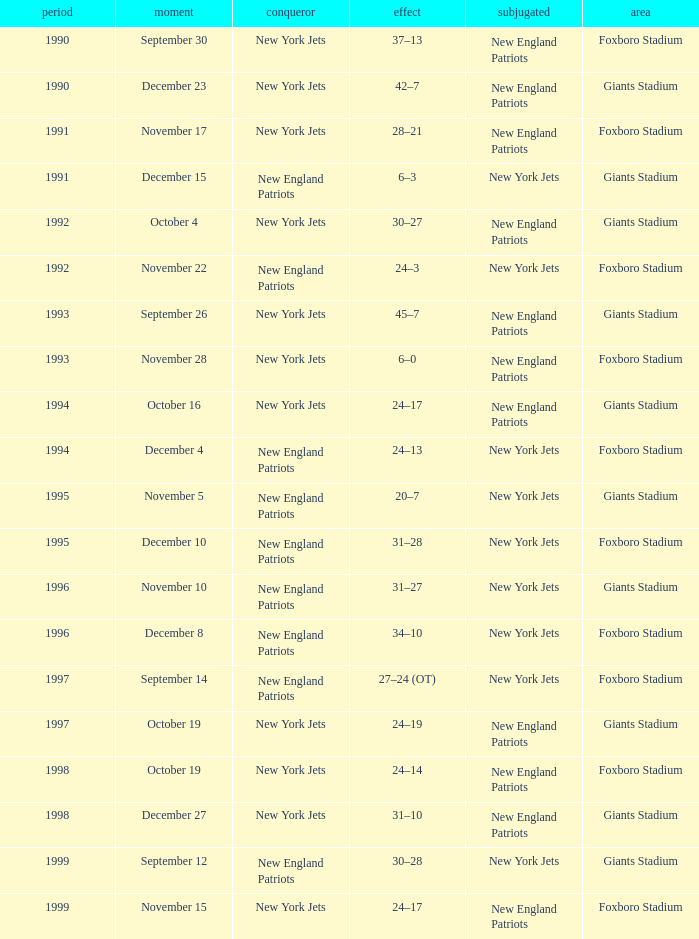What team was the lower when the winner was the new york jets, and a Year earlier than 1994, and a Result of 37–13? New England Patriots. Could you help me parse every detail presented in this table? {'header': ['period', 'moment', 'conqueror', 'effect', 'subjugated', 'area'], 'rows': [['1990', 'September 30', 'New York Jets', '37–13', 'New England Patriots', 'Foxboro Stadium'], ['1990', 'December 23', 'New York Jets', '42–7', 'New England Patriots', 'Giants Stadium'], ['1991', 'November 17', 'New York Jets', '28–21', 'New England Patriots', 'Foxboro Stadium'], ['1991', 'December 15', 'New England Patriots', '6–3', 'New York Jets', 'Giants Stadium'], ['1992', 'October 4', 'New York Jets', '30–27', 'New England Patriots', 'Giants Stadium'], ['1992', 'November 22', 'New England Patriots', '24–3', 'New York Jets', 'Foxboro Stadium'], ['1993', 'September 26', 'New York Jets', '45–7', 'New England Patriots', 'Giants Stadium'], ['1993', 'November 28', 'New York Jets', '6–0', 'New England Patriots', 'Foxboro Stadium'], ['1994', 'October 16', 'New York Jets', '24–17', 'New England Patriots', 'Giants Stadium'], ['1994', 'December 4', 'New England Patriots', '24–13', 'New York Jets', 'Foxboro Stadium'], ['1995', 'November 5', 'New England Patriots', '20–7', 'New York Jets', 'Giants Stadium'], ['1995', 'December 10', 'New England Patriots', '31–28', 'New York Jets', 'Foxboro Stadium'], ['1996', 'November 10', 'New England Patriots', '31–27', 'New York Jets', 'Giants Stadium'], ['1996', 'December 8', 'New England Patriots', '34–10', 'New York Jets', 'Foxboro Stadium'], ['1997', 'September 14', 'New England Patriots', '27–24 (OT)', 'New York Jets', 'Foxboro Stadium'], ['1997', 'October 19', 'New York Jets', '24–19', 'New England Patriots', 'Giants Stadium'], ['1998', 'October 19', 'New York Jets', '24–14', 'New England Patriots', 'Foxboro Stadium'], ['1998', 'December 27', 'New York Jets', '31–10', 'New England Patriots', 'Giants Stadium'], ['1999', 'September 12', 'New England Patriots', '30–28', 'New York Jets', 'Giants Stadium'], ['1999', 'November 15', 'New York Jets', '24–17', 'New England Patriots', 'Foxboro Stadium']]} 